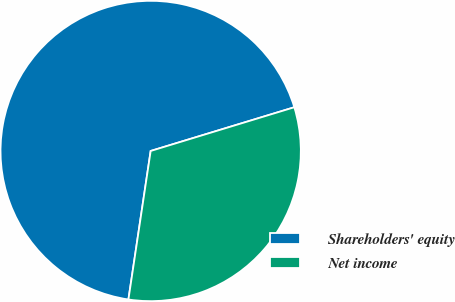Convert chart to OTSL. <chart><loc_0><loc_0><loc_500><loc_500><pie_chart><fcel>Shareholders' equity<fcel>Net income<nl><fcel>67.93%<fcel>32.07%<nl></chart> 